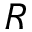Convert formula to latex. <formula><loc_0><loc_0><loc_500><loc_500>R</formula> 